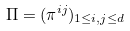<formula> <loc_0><loc_0><loc_500><loc_500>\Pi = ( \pi ^ { i j } ) _ { 1 \leq i , j \leq d }</formula> 